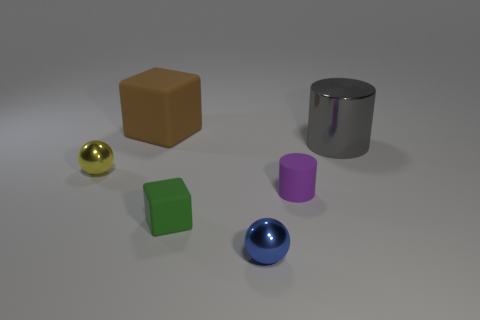What materials do the objects display, and what does their arrangement tell us? The objects in the image display a variety of materials including a glossy, reflective surface on the silver cylinder and the small, shiny spheres. The rubber block has a matte finish. Their arrangement appears random and could potentially symbolize diversity and uniqueness. 